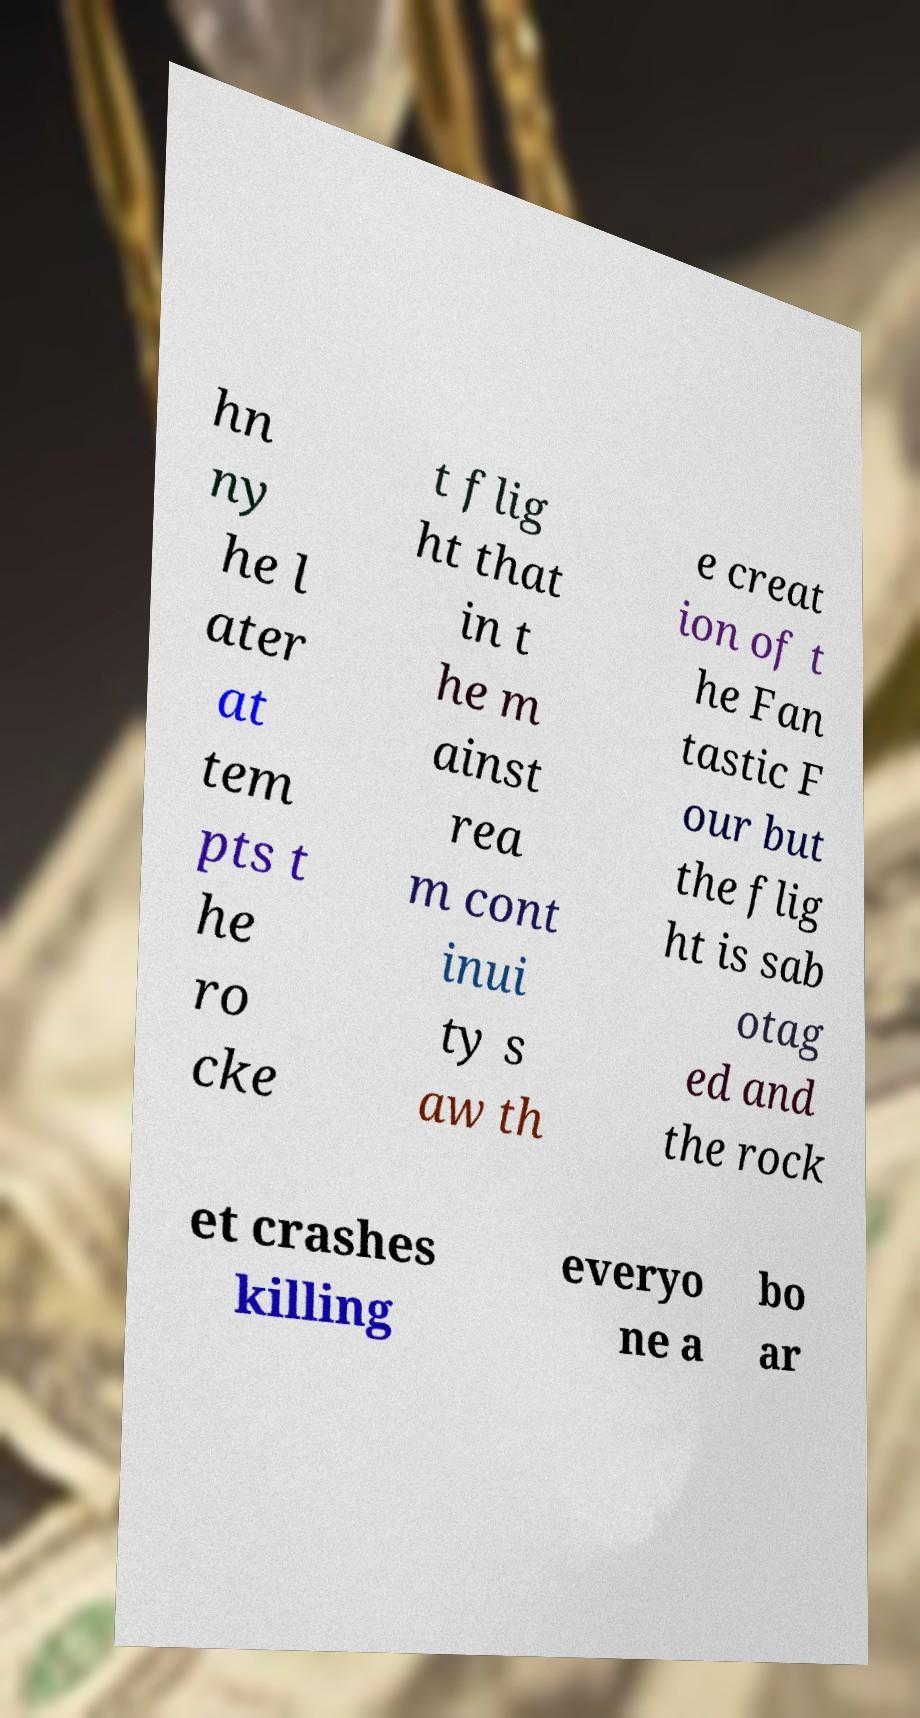I need the written content from this picture converted into text. Can you do that? hn ny he l ater at tem pts t he ro cke t flig ht that in t he m ainst rea m cont inui ty s aw th e creat ion of t he Fan tastic F our but the flig ht is sab otag ed and the rock et crashes killing everyo ne a bo ar 